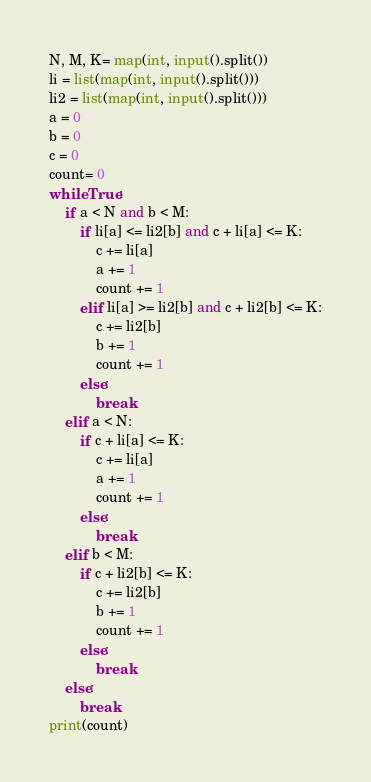Convert code to text. <code><loc_0><loc_0><loc_500><loc_500><_Python_>N, M, K= map(int, input().split())
li = list(map(int, input().split()))
li2 = list(map(int, input().split()))
a = 0
b = 0
c = 0
count= 0
while True:
    if a < N and b < M:
        if li[a] <= li2[b] and c + li[a] <= K:
            c += li[a]
            a += 1
            count += 1
        elif li[a] >= li2[b] and c + li2[b] <= K:
            c += li2[b]
            b += 1
            count += 1
        else:
            break
    elif a < N:
        if c + li[a] <= K:
            c += li[a]
            a += 1
            count += 1
        else:
            break
    elif b < M:
        if c + li2[b] <= K:
            c += li2[b]
            b += 1
            count += 1
        else:
            break
    else:
        break
print(count)
</code> 